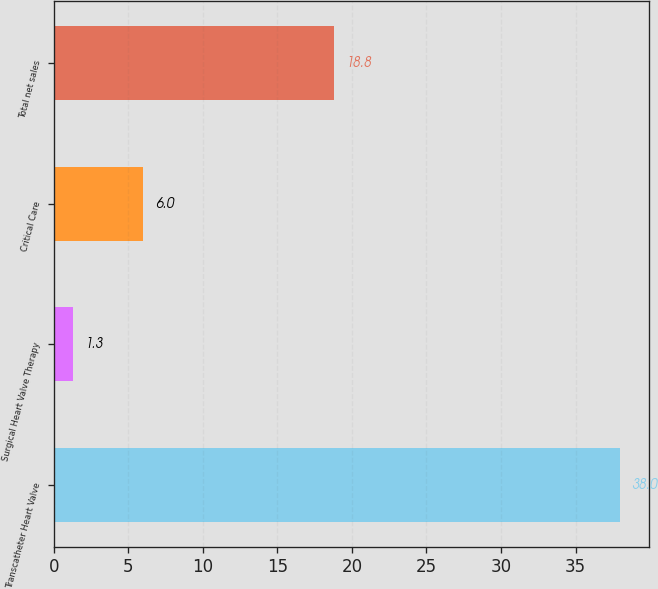Convert chart. <chart><loc_0><loc_0><loc_500><loc_500><bar_chart><fcel>Transcatheter Heart Valve<fcel>Surgical Heart Valve Therapy<fcel>Critical Care<fcel>Total net sales<nl><fcel>38<fcel>1.3<fcel>6<fcel>18.8<nl></chart> 